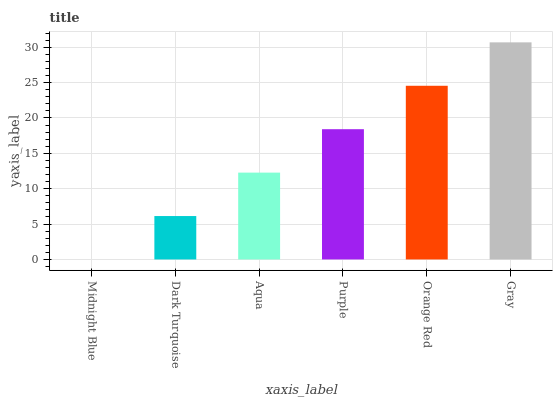Is Midnight Blue the minimum?
Answer yes or no. Yes. Is Gray the maximum?
Answer yes or no. Yes. Is Dark Turquoise the minimum?
Answer yes or no. No. Is Dark Turquoise the maximum?
Answer yes or no. No. Is Dark Turquoise greater than Midnight Blue?
Answer yes or no. Yes. Is Midnight Blue less than Dark Turquoise?
Answer yes or no. Yes. Is Midnight Blue greater than Dark Turquoise?
Answer yes or no. No. Is Dark Turquoise less than Midnight Blue?
Answer yes or no. No. Is Purple the high median?
Answer yes or no. Yes. Is Aqua the low median?
Answer yes or no. Yes. Is Dark Turquoise the high median?
Answer yes or no. No. Is Orange Red the low median?
Answer yes or no. No. 